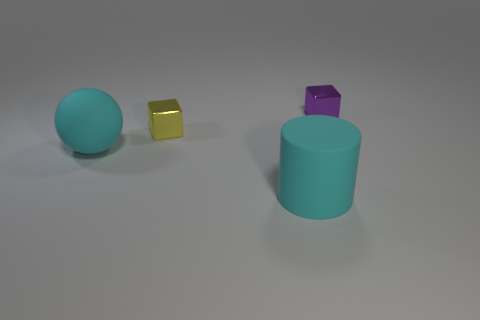What shape is the tiny thing on the left side of the tiny purple metallic thing?
Your answer should be very brief. Cube. There is a big sphere that is the same color as the cylinder; what material is it?
Provide a short and direct response. Rubber. How many other objects are the same material as the large cyan ball?
Make the answer very short. 1. There is a purple shiny object; does it have the same shape as the tiny metal object that is left of the large cylinder?
Your answer should be very brief. Yes. There is a large thing that is the same material as the cyan cylinder; what is its shape?
Ensure brevity in your answer.  Sphere. Are there more tiny metal objects that are on the left side of the purple shiny cube than large cyan spheres that are behind the big matte cylinder?
Offer a very short reply. No. What number of objects are gray cubes or small cubes?
Give a very brief answer. 2. What number of other objects are there of the same color as the matte cylinder?
Your answer should be compact. 1. What is the shape of the cyan matte thing that is the same size as the cyan ball?
Keep it short and to the point. Cylinder. The object that is to the left of the tiny yellow cube is what color?
Give a very brief answer. Cyan. 